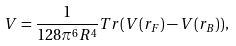<formula> <loc_0><loc_0><loc_500><loc_500>V = \frac { 1 } { 1 2 8 \pi ^ { 6 } R ^ { 4 } } T r ( V ( r _ { F } ) - V ( r _ { B } ) ) ,</formula> 